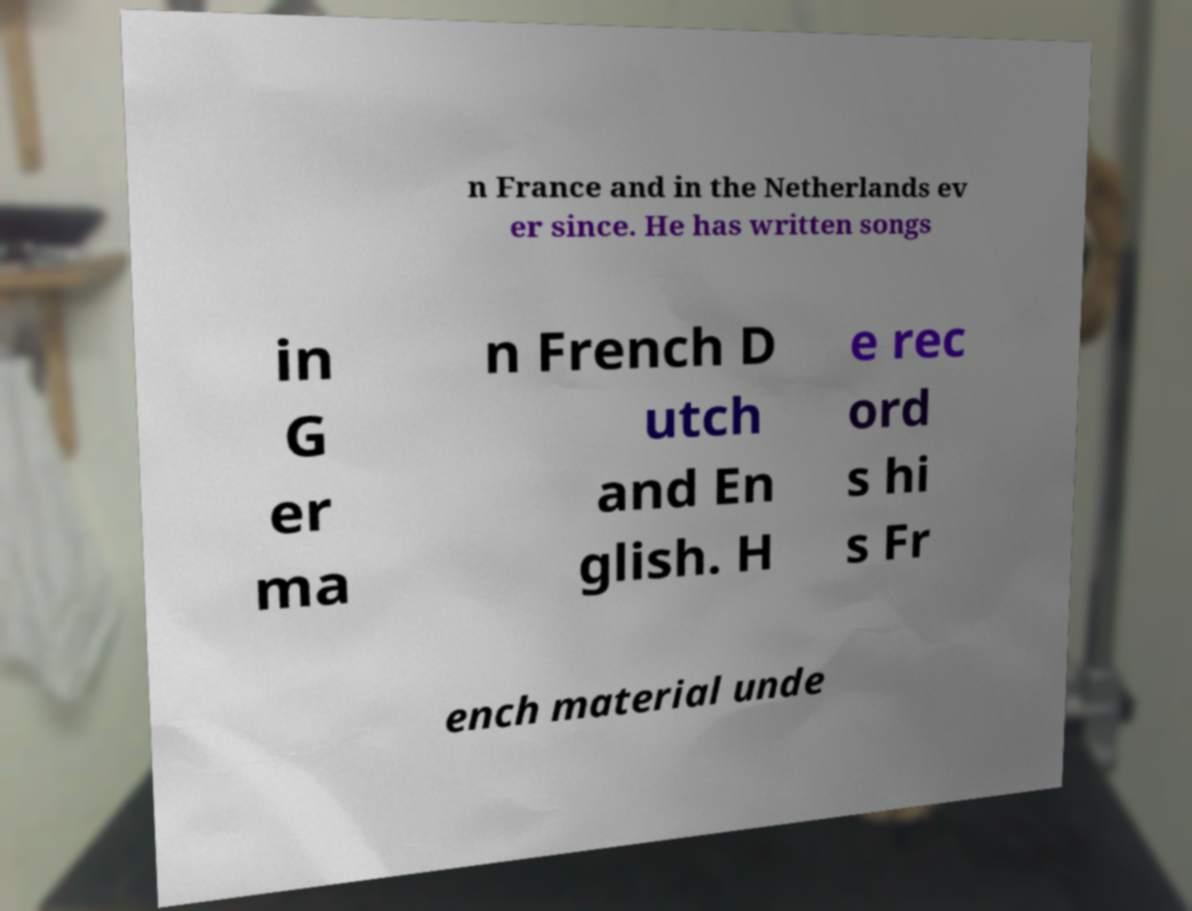I need the written content from this picture converted into text. Can you do that? n France and in the Netherlands ev er since. He has written songs in G er ma n French D utch and En glish. H e rec ord s hi s Fr ench material unde 